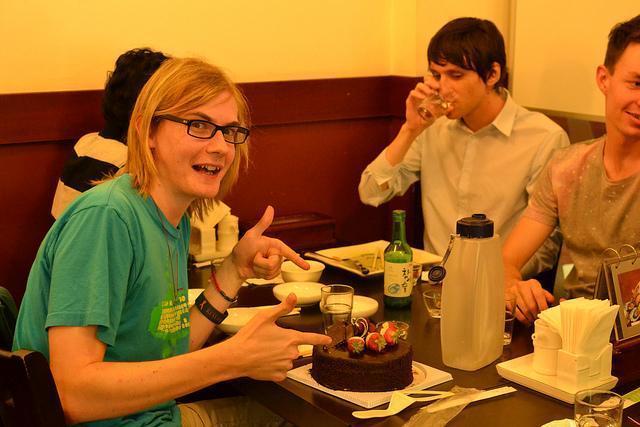How many people are in the shot?
Give a very brief answer. 4. How many people can be seen?
Give a very brief answer. 4. How many bottles are visible?
Give a very brief answer. 2. How many sheep are there?
Give a very brief answer. 0. 